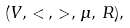<formula> <loc_0><loc_0><loc_500><loc_500>( V , \, < \, , \, > , \, \mu , \, R ) ,</formula> 